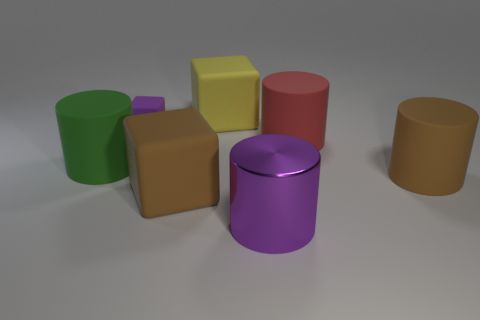Subtract 1 cylinders. How many cylinders are left? 3 Subtract all yellow cubes. Subtract all green cylinders. How many cubes are left? 2 Add 3 big green metallic balls. How many objects exist? 10 Subtract all blocks. How many objects are left? 4 Add 6 tiny matte objects. How many tiny matte objects are left? 7 Add 1 big rubber cubes. How many big rubber cubes exist? 3 Subtract 1 red cylinders. How many objects are left? 6 Subtract all large red cylinders. Subtract all large purple shiny objects. How many objects are left? 5 